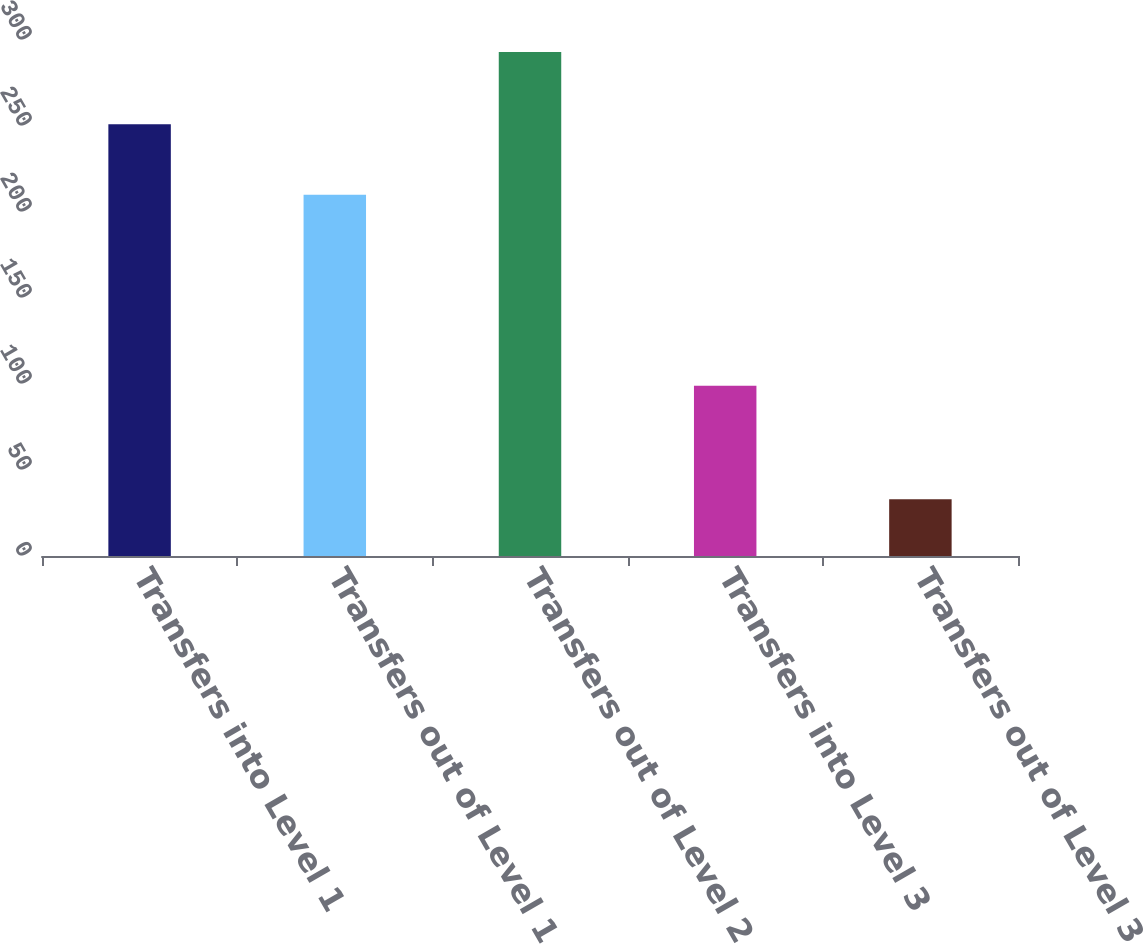Convert chart. <chart><loc_0><loc_0><loc_500><loc_500><bar_chart><fcel>Transfers into Level 1<fcel>Transfers out of Level 1<fcel>Transfers out of Level 2<fcel>Transfers into Level 3<fcel>Transfers out of Level 3<nl><fcel>251<fcel>210<fcel>293<fcel>99<fcel>33<nl></chart> 